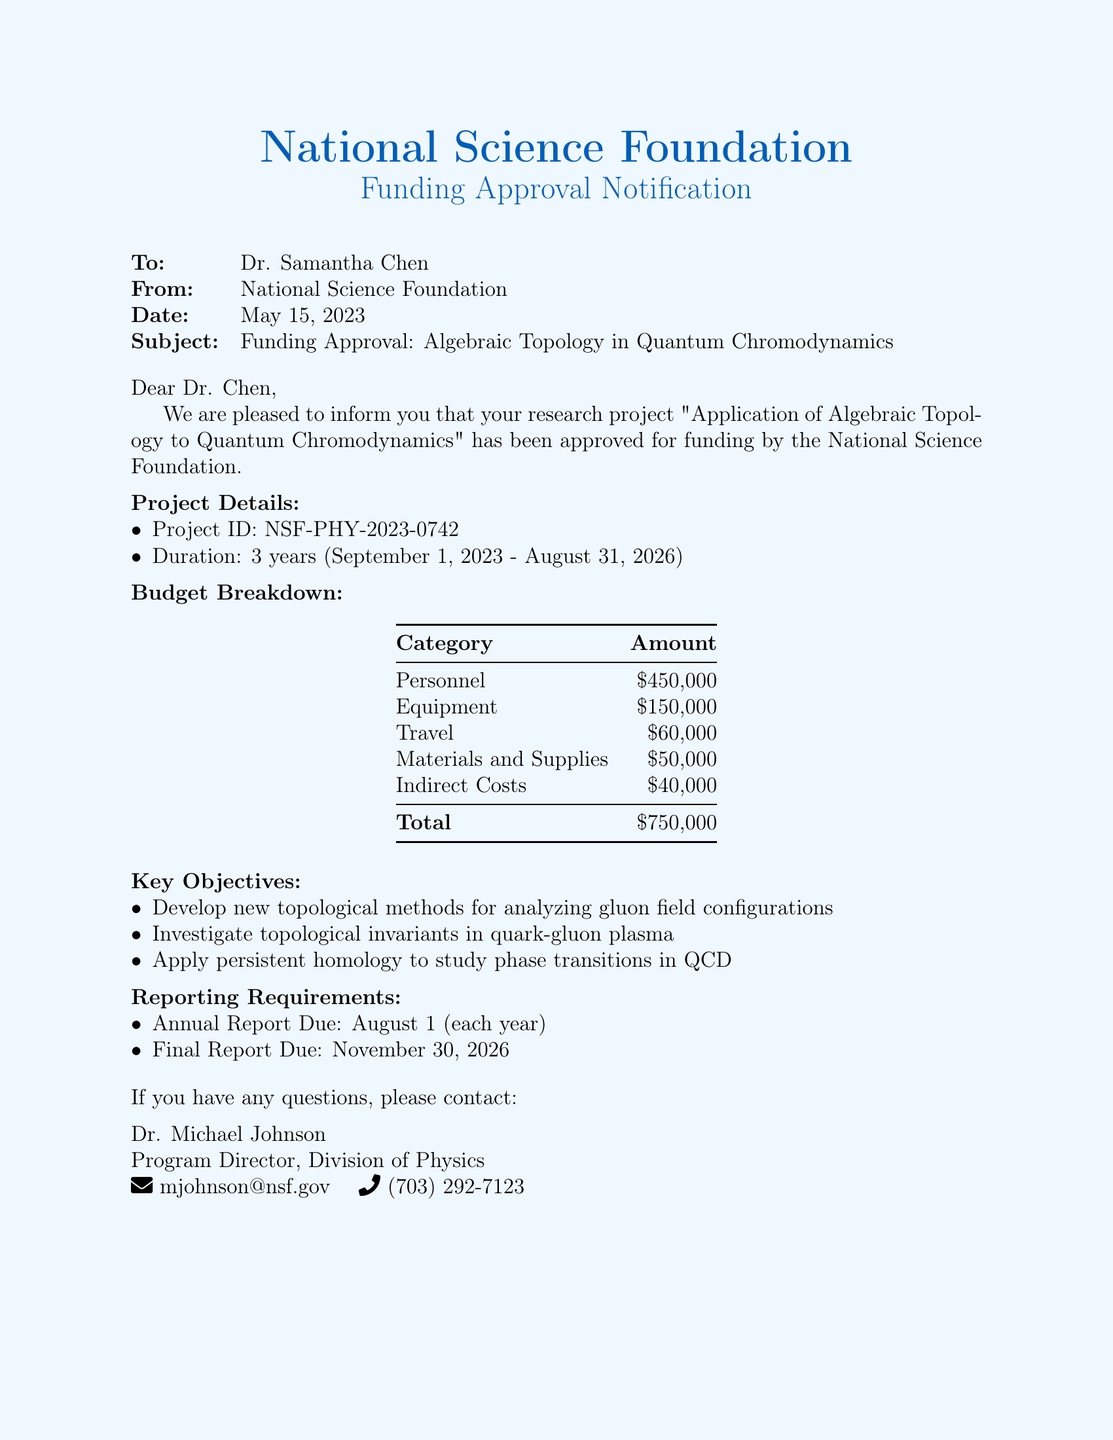What is the project ID? The project ID is specifically mentioned under the project details section.
Answer: NSF-PHY-2023-0742 What is the total budget for the project? The total budget can be found in the budget breakdown section of the document.
Answer: $750,000 Who is the contact person for questions? The document explicitly states the person to contact for any questions regarding the funding.
Answer: Dr. Michael Johnson When is the final report due? The due date for the final report is listed in the reporting requirements section.
Answer: November 30, 2026 How long is the project duration? The project duration is detailed in the project details section, specifying the start and end dates.
Answer: 3 years What is the budget allocated for travel? The budget category for travel is listed in the budget breakdown.
Answer: $60,000 What are the key objectives? The key objectives of the project are outlined in a bulleted list in the document.
Answer: Develop new topological methods for analyzing gluon field configurations What is the due date for the annual report? The due date for the annual report is mentioned in the reporting requirements.
Answer: August 1 How much is allocated for personnel? The personnel budget is specifically listed in the budget breakdown section.
Answer: $450,000 